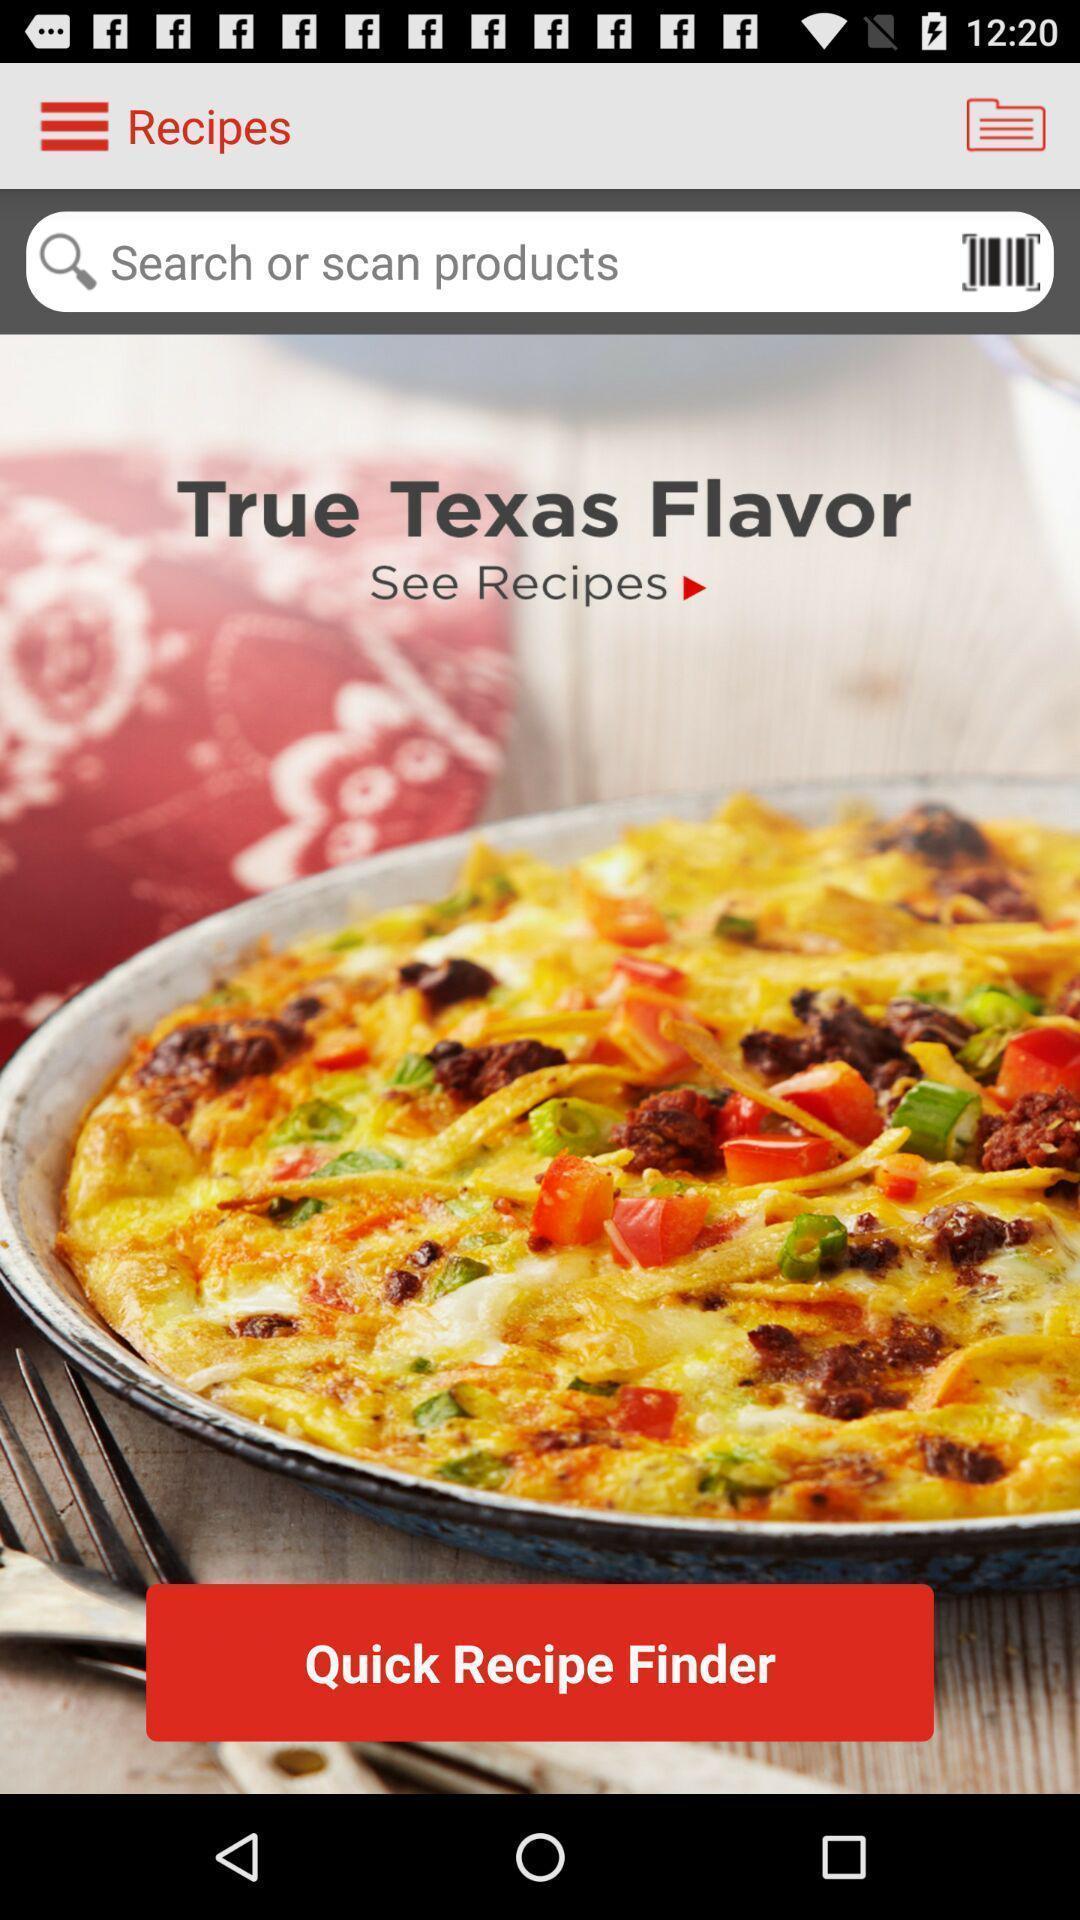Summarize the information in this screenshot. Welcome page of a food app. 